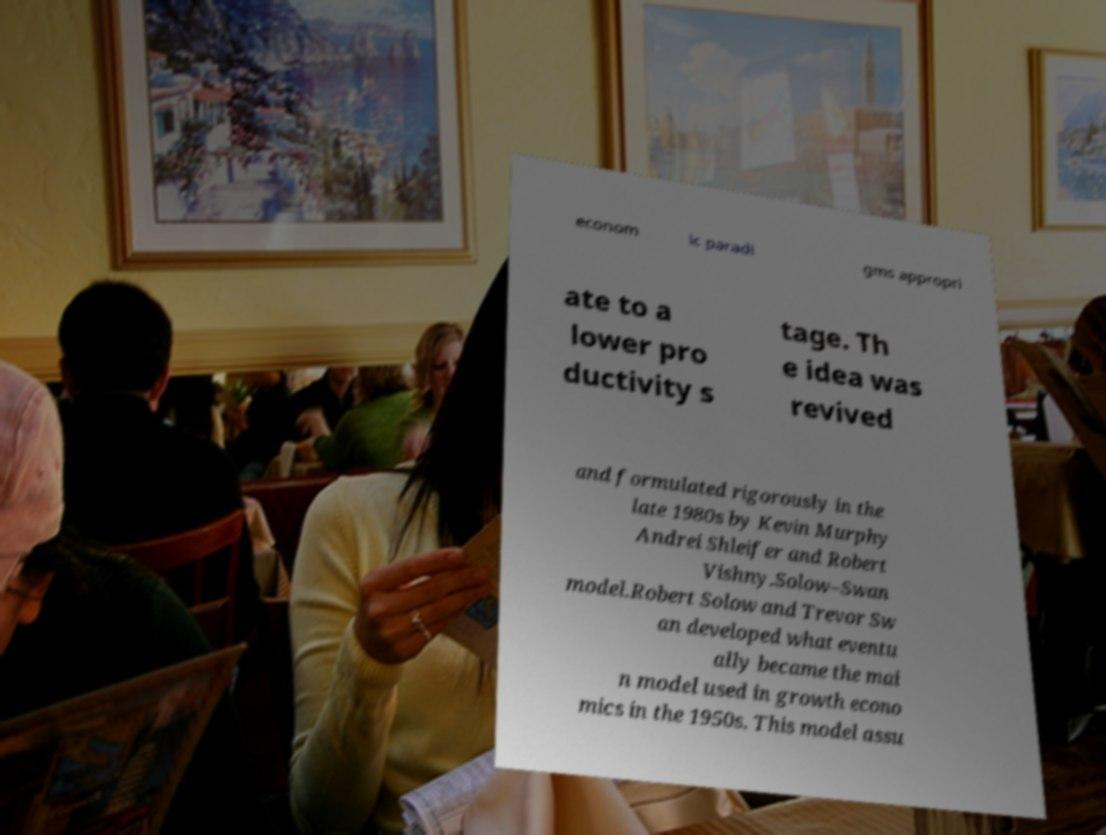For documentation purposes, I need the text within this image transcribed. Could you provide that? econom ic paradi gms appropri ate to a lower pro ductivity s tage. Th e idea was revived and formulated rigorously in the late 1980s by Kevin Murphy Andrei Shleifer and Robert Vishny.Solow–Swan model.Robert Solow and Trevor Sw an developed what eventu ally became the mai n model used in growth econo mics in the 1950s. This model assu 